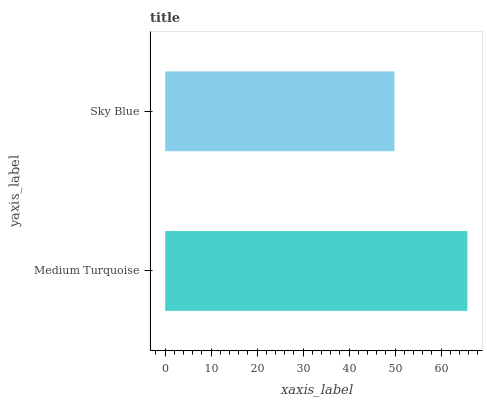Is Sky Blue the minimum?
Answer yes or no. Yes. Is Medium Turquoise the maximum?
Answer yes or no. Yes. Is Sky Blue the maximum?
Answer yes or no. No. Is Medium Turquoise greater than Sky Blue?
Answer yes or no. Yes. Is Sky Blue less than Medium Turquoise?
Answer yes or no. Yes. Is Sky Blue greater than Medium Turquoise?
Answer yes or no. No. Is Medium Turquoise less than Sky Blue?
Answer yes or no. No. Is Medium Turquoise the high median?
Answer yes or no. Yes. Is Sky Blue the low median?
Answer yes or no. Yes. Is Sky Blue the high median?
Answer yes or no. No. Is Medium Turquoise the low median?
Answer yes or no. No. 